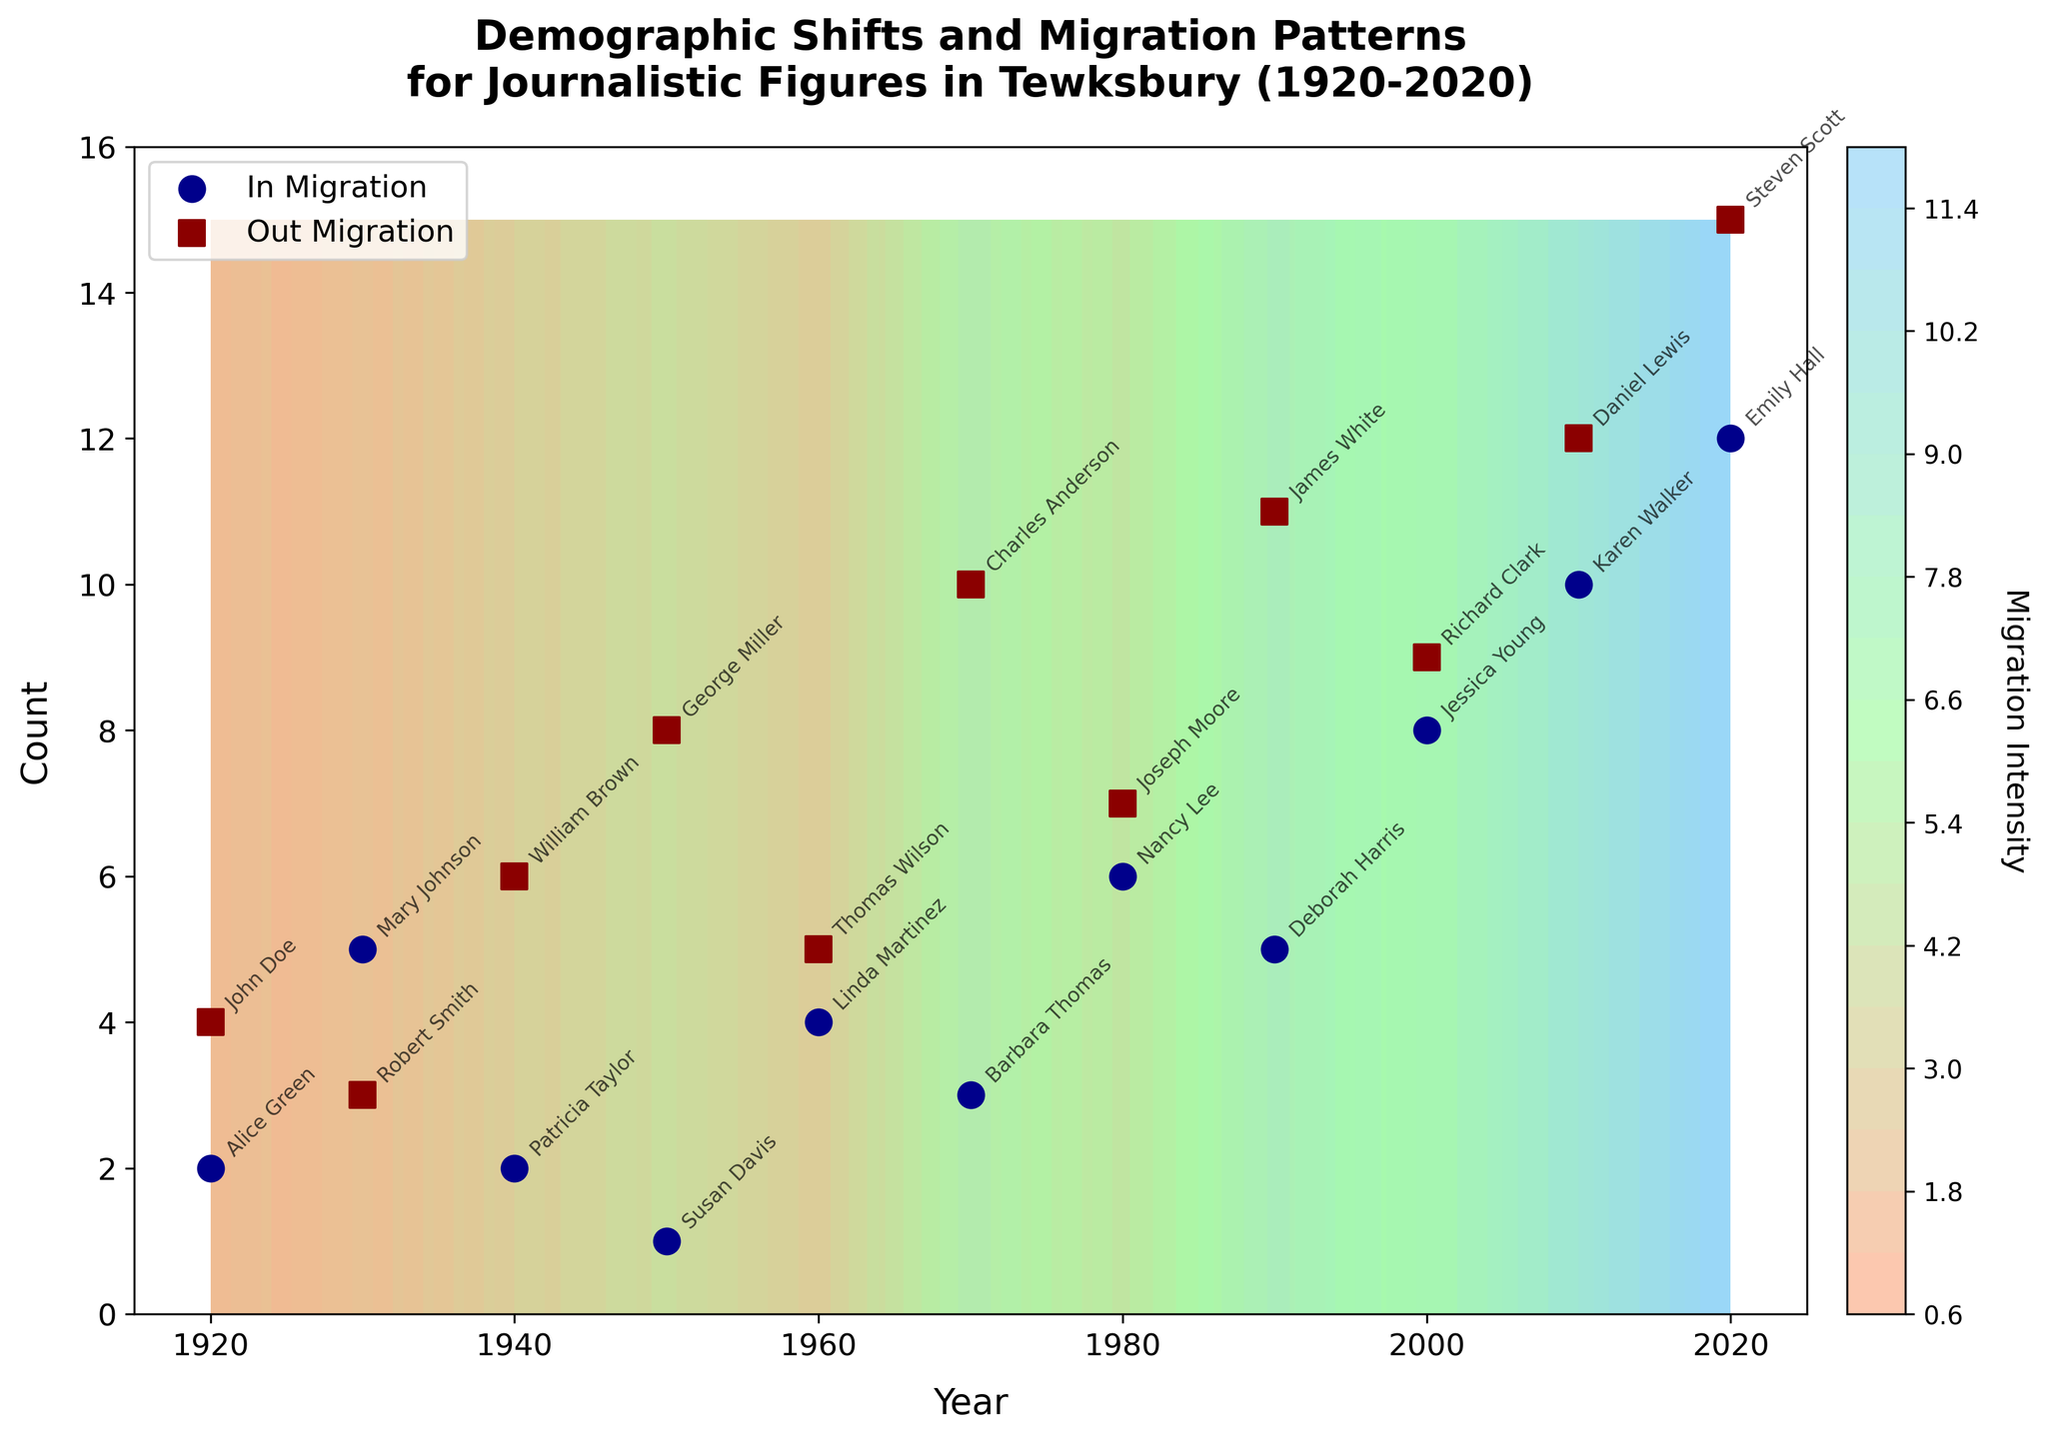How many migration data points are there in total? There are two types of migration data points for each year from 1920 to 2020, which results in 21 years. For each year, there’s one 'In' and one 'Out' data point. So, total points = 21 * 2.
Answer: 42 Which year shows the highest 'Out' migration count? By looking at the figure, the highest data point for 'Out' migration is noted in 2020 with a count of 15.
Answer: 2020 What is the overall trend in 'In' migration counts from 1920 to 2020? From observing the contour lines and data points, the 'In' migration counts generally show a gradual increase over the years, peaking at 12 in 2020.
Answer: Increasing Compare the 'In' and 'Out' migration counts in 1990. Which one is higher and by how much? In 1990 'In' migration count is 5 and 'Out' migration is 11. The 'Out' count is higher by (11 - 5) = 6.
Answer: 6 What is the average 'Out' migration count for the decades 1950s and 2000s? First, sum the 'Out' counts for each decade. 1950s: (8), 1960s: (5), 1970s: (10), 1980s: (7), 1990s: (11), 2000s: (9), 2010s: (12), 2020s: (15). Average for 1950s: 8, and for 2000s: (9+12+15)/3 = 12.
Answer: 6, 12 Identify the year with the sharpest increase in 'In' migration count compared to the previous decade. Comparing 'In' counts for decades: 1920 (2), 1930 (5), 1940 (2), 1950 (1), 1960 (4), 1970 (3), 1980 (6), 1990 (5), 2000 (8), 2010 (10), 2020 (12). The biggest increase is from 1950 to 1960: 4 - 1 = 3.
Answer: 1960 Which year displays the widest gap between 'In' and 'Out' migration counts? By visual inspection, the widest gap is in 1990, where 'Out' is 11 and 'In' is 5. The gap is 11 - 5 = 6.
Answer: 1990 Is there any year where 'In' migration exceeded 'Out' migration, and if so, which year? By examining the data points, there is no year where 'In' migration exceeds 'Out' migration.
Answer: No 